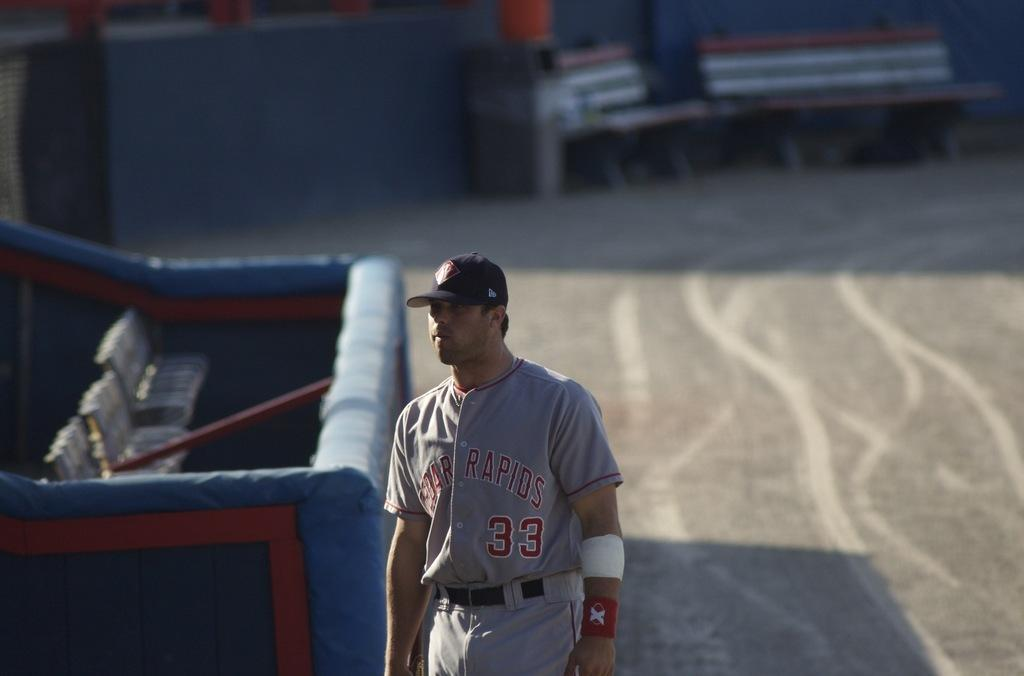<image>
Describe the image concisely. Baseball player wearing the number 33 on his chest. 